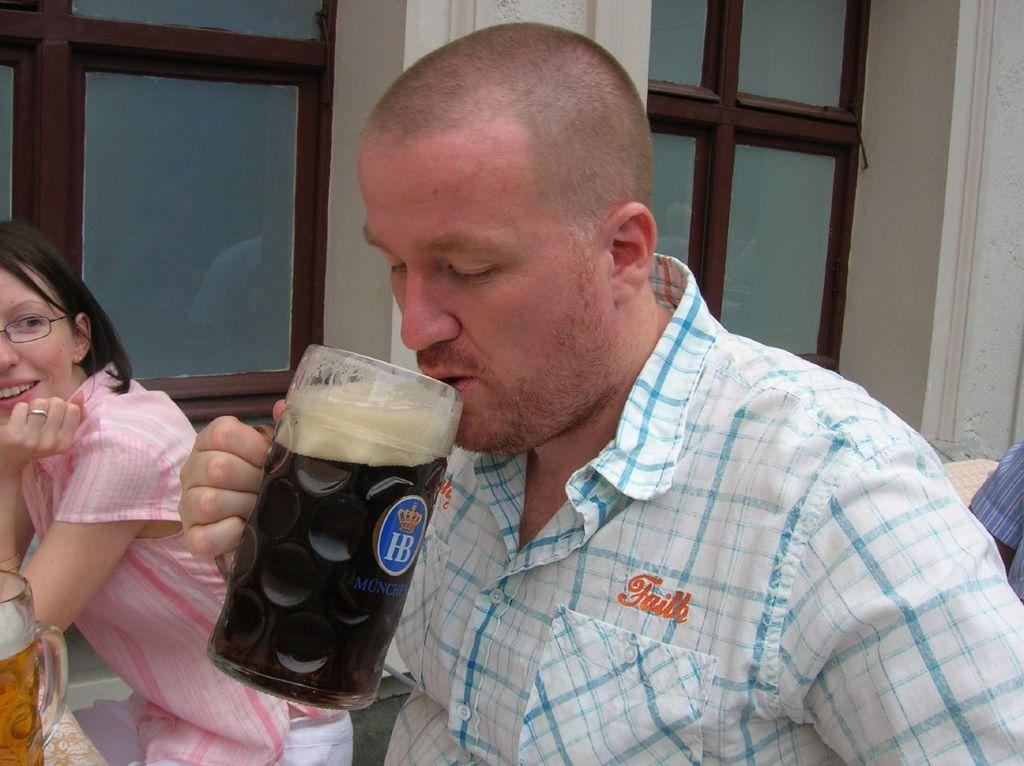Who is the main subject in the center of the image? There is a man in the center of the image. What is the man doing in the image? The man is drinking a cool drink. Who is standing beside the man? There is a lady beside the man. What expression does the lady have in the image? The lady is smiling. What type of beetle can be seen crawling on the man's shoulder in the image? There is no beetle present on the man's shoulder in the image. What rhythm is the man tapping his foot to in the image? There is no indication of any rhythm or foot-tapping in the image. 